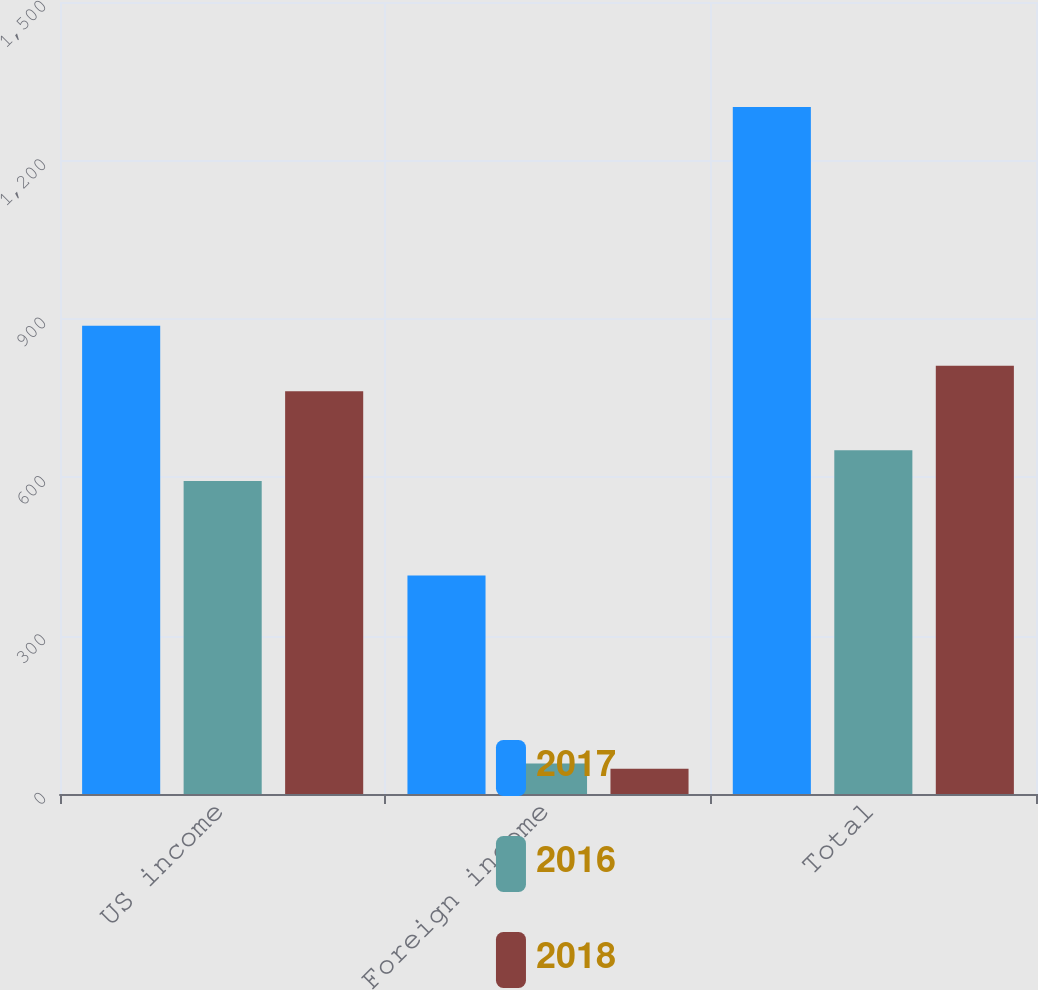<chart> <loc_0><loc_0><loc_500><loc_500><stacked_bar_chart><ecel><fcel>US income<fcel>Foreign income<fcel>Total<nl><fcel>2017<fcel>887<fcel>414<fcel>1301<nl><fcel>2016<fcel>593<fcel>58<fcel>651<nl><fcel>2018<fcel>763<fcel>48<fcel>811<nl></chart> 